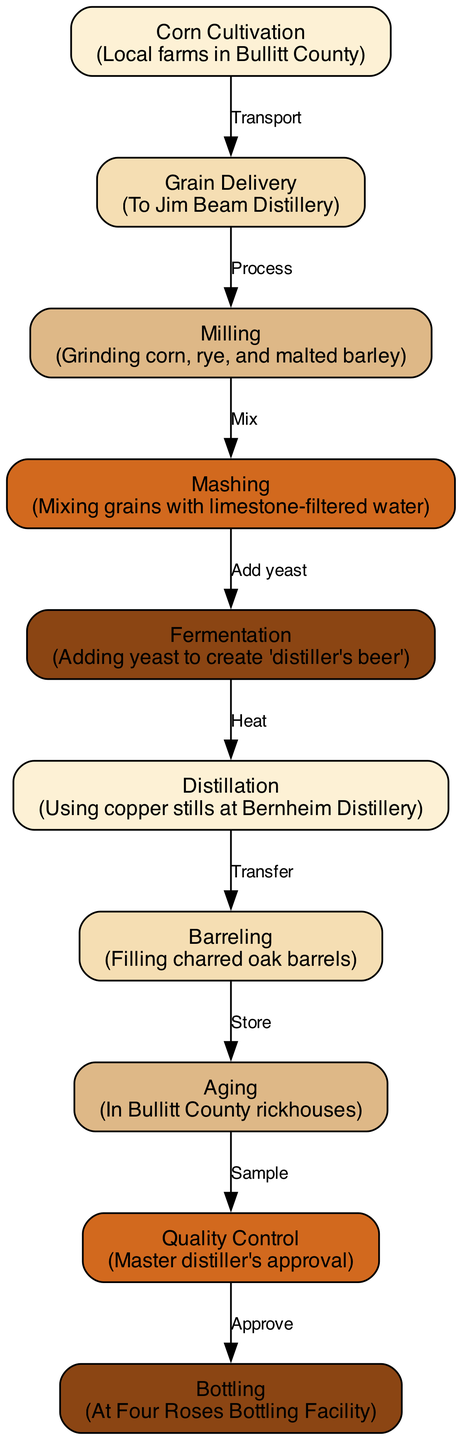What node follows "Corn Cultivation"? The edge from "Corn Cultivation" indicates a transport to the next node, which is "Grain Delivery". Therefore, the node following "Corn Cultivation" is "Grain Delivery".
Answer: Grain Delivery How many nodes are there in the diagram? By counting the nodes listed, there are a total of ten distinct stages in the bourbon production process.
Answer: 10 What is the relationship between "Aging" and "Quality Control"? The edge connects "Aging" to "Quality Control" with a label "Sample", indicating that samples are taken from the aging process for quality assurance.
Answer: Sample Which facility handles the bottling process? The diagram specifies that the bottling process takes place at the "Four Roses Bottling Facility", directly indicating the facility involved.
Answer: Four Roses Bottling Facility What process comes immediately after fermentation? The edge indicates that after "Fermentation", the process flows to "Distillation", showing the direct succession of these stages.
Answer: Distillation What is the last step before bottling in the bourbon production process? Tracing the flow back from "Bottling", the previous node is "Quality Control", indicating it is the last step before the final bottling.
Answer: Quality Control Which distillery uses copper stills for distillation? According to the diagram, "Bernheim Distillery" is specified as the location where distillation occurs using copper stills, identifying the distillery in the process.
Answer: Bernheim Distillery What is the first step in the bourbon production process depicted in the diagram? The diagram starts with "Corn Cultivation", marking it as the initial step of the bourbon production process in the flow.
Answer: Corn Cultivation Which two nodes are connected with the relationship "Add yeast"? The edge labeled "Add yeast" connects "Mashing" to "Fermentation", illustrating this specific relationship between the two processes.
Answer: Mashing and Fermentation Which process directly follows the "Barreling" step? The diagram shows that the next operation following "Barreling" is "Aging", revealing the sequence in the production cycle.
Answer: Aging 